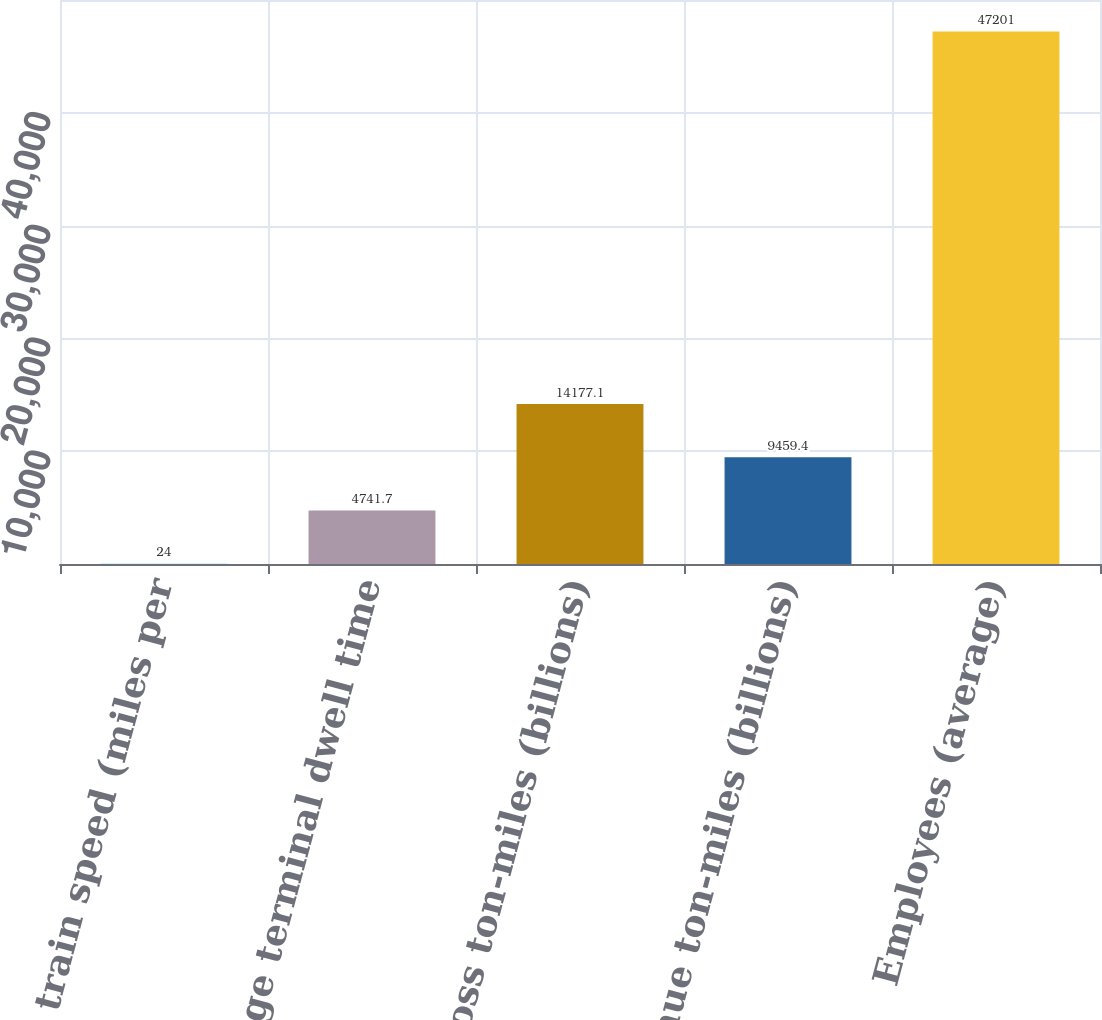Convert chart to OTSL. <chart><loc_0><loc_0><loc_500><loc_500><bar_chart><fcel>Average train speed (miles per<fcel>Average terminal dwell time<fcel>Gross ton-miles (billions)<fcel>Revenue ton-miles (billions)<fcel>Employees (average)<nl><fcel>24<fcel>4741.7<fcel>14177.1<fcel>9459.4<fcel>47201<nl></chart> 